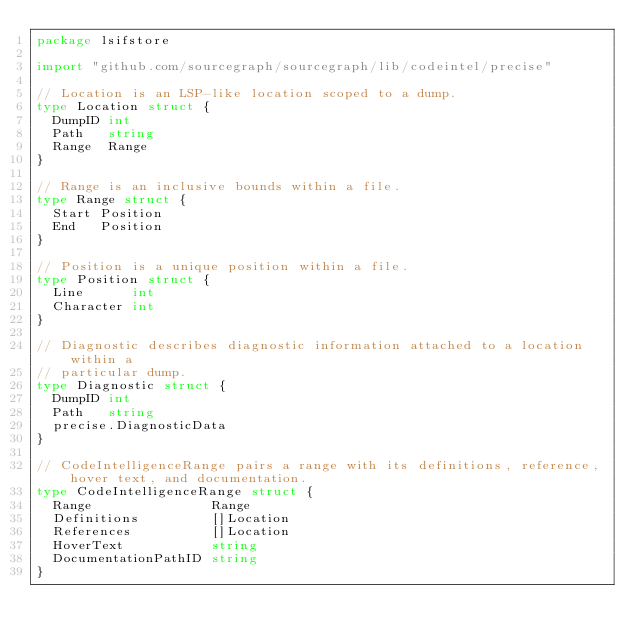Convert code to text. <code><loc_0><loc_0><loc_500><loc_500><_Go_>package lsifstore

import "github.com/sourcegraph/sourcegraph/lib/codeintel/precise"

// Location is an LSP-like location scoped to a dump.
type Location struct {
	DumpID int
	Path   string
	Range  Range
}

// Range is an inclusive bounds within a file.
type Range struct {
	Start Position
	End   Position
}

// Position is a unique position within a file.
type Position struct {
	Line      int
	Character int
}

// Diagnostic describes diagnostic information attached to a location within a
// particular dump.
type Diagnostic struct {
	DumpID int
	Path   string
	precise.DiagnosticData
}

// CodeIntelligenceRange pairs a range with its definitions, reference, hover text, and documentation.
type CodeIntelligenceRange struct {
	Range               Range
	Definitions         []Location
	References          []Location
	HoverText           string
	DocumentationPathID string
}
</code> 